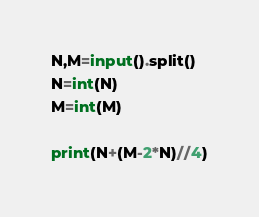<code> <loc_0><loc_0><loc_500><loc_500><_Python_>N,M=input().split()
N=int(N)
M=int(M)

print(N+(M-2*N)//4)
</code> 